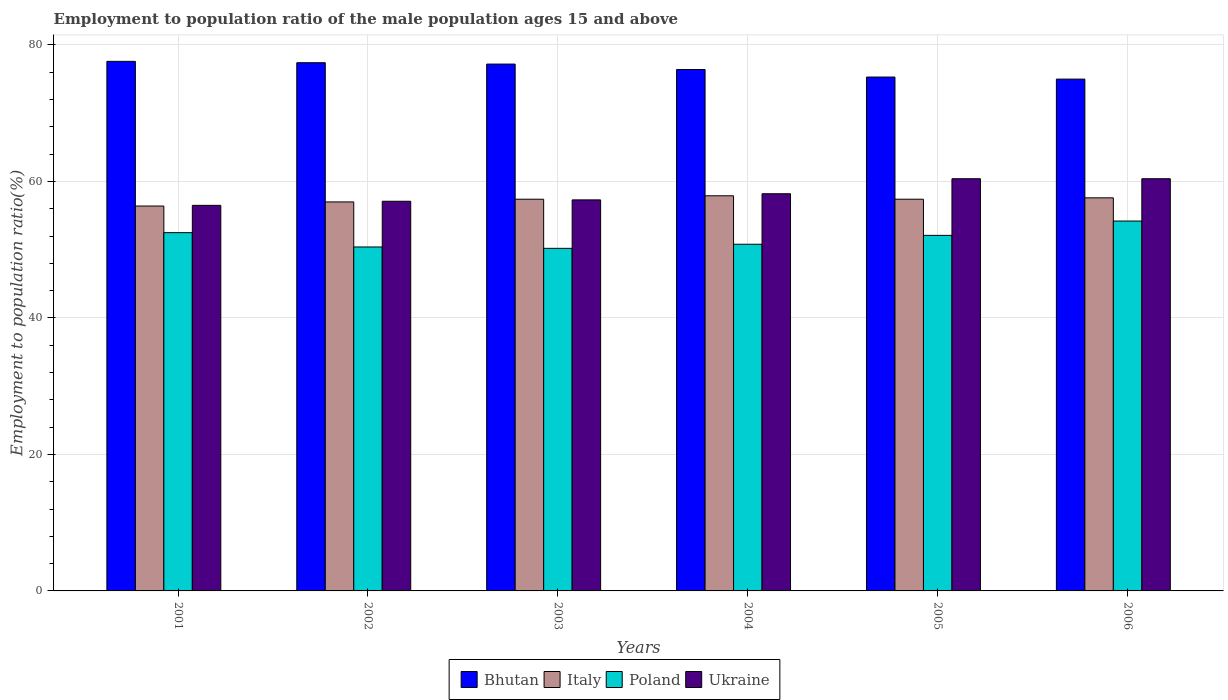How many different coloured bars are there?
Your response must be concise. 4. Are the number of bars per tick equal to the number of legend labels?
Your response must be concise. Yes. Are the number of bars on each tick of the X-axis equal?
Provide a short and direct response. Yes. How many bars are there on the 6th tick from the left?
Your response must be concise. 4. What is the label of the 4th group of bars from the left?
Offer a very short reply. 2004. In how many cases, is the number of bars for a given year not equal to the number of legend labels?
Provide a succinct answer. 0. What is the employment to population ratio in Ukraine in 2002?
Offer a very short reply. 57.1. Across all years, what is the maximum employment to population ratio in Ukraine?
Offer a very short reply. 60.4. Across all years, what is the minimum employment to population ratio in Ukraine?
Your answer should be compact. 56.5. What is the total employment to population ratio in Ukraine in the graph?
Your answer should be very brief. 349.9. What is the difference between the employment to population ratio in Italy in 2001 and that in 2003?
Make the answer very short. -1. What is the difference between the employment to population ratio in Poland in 2001 and the employment to population ratio in Bhutan in 2004?
Your response must be concise. -23.9. What is the average employment to population ratio in Ukraine per year?
Your answer should be very brief. 58.32. In the year 2004, what is the difference between the employment to population ratio in Poland and employment to population ratio in Bhutan?
Your answer should be compact. -25.6. What is the ratio of the employment to population ratio in Ukraine in 2002 to that in 2003?
Your response must be concise. 1. Is the difference between the employment to population ratio in Poland in 2003 and 2004 greater than the difference between the employment to population ratio in Bhutan in 2003 and 2004?
Provide a short and direct response. No. What is the difference between the highest and the second highest employment to population ratio in Italy?
Offer a terse response. 0.3. In how many years, is the employment to population ratio in Bhutan greater than the average employment to population ratio in Bhutan taken over all years?
Your answer should be very brief. 3. Is it the case that in every year, the sum of the employment to population ratio in Bhutan and employment to population ratio in Poland is greater than the sum of employment to population ratio in Ukraine and employment to population ratio in Italy?
Offer a terse response. No. What does the 4th bar from the left in 2005 represents?
Offer a very short reply. Ukraine. Is it the case that in every year, the sum of the employment to population ratio in Poland and employment to population ratio in Italy is greater than the employment to population ratio in Ukraine?
Offer a terse response. Yes. How many bars are there?
Ensure brevity in your answer.  24. Are all the bars in the graph horizontal?
Give a very brief answer. No. How many years are there in the graph?
Ensure brevity in your answer.  6. Does the graph contain any zero values?
Offer a terse response. No. How many legend labels are there?
Offer a terse response. 4. How are the legend labels stacked?
Your answer should be compact. Horizontal. What is the title of the graph?
Offer a very short reply. Employment to population ratio of the male population ages 15 and above. Does "Venezuela" appear as one of the legend labels in the graph?
Keep it short and to the point. No. What is the label or title of the X-axis?
Offer a very short reply. Years. What is the label or title of the Y-axis?
Make the answer very short. Employment to population ratio(%). What is the Employment to population ratio(%) in Bhutan in 2001?
Your answer should be very brief. 77.6. What is the Employment to population ratio(%) in Italy in 2001?
Offer a very short reply. 56.4. What is the Employment to population ratio(%) of Poland in 2001?
Provide a short and direct response. 52.5. What is the Employment to population ratio(%) in Ukraine in 2001?
Your response must be concise. 56.5. What is the Employment to population ratio(%) of Bhutan in 2002?
Give a very brief answer. 77.4. What is the Employment to population ratio(%) in Italy in 2002?
Your answer should be compact. 57. What is the Employment to population ratio(%) in Poland in 2002?
Your response must be concise. 50.4. What is the Employment to population ratio(%) in Ukraine in 2002?
Your answer should be compact. 57.1. What is the Employment to population ratio(%) in Bhutan in 2003?
Offer a terse response. 77.2. What is the Employment to population ratio(%) of Italy in 2003?
Ensure brevity in your answer.  57.4. What is the Employment to population ratio(%) in Poland in 2003?
Offer a terse response. 50.2. What is the Employment to population ratio(%) of Ukraine in 2003?
Make the answer very short. 57.3. What is the Employment to population ratio(%) in Bhutan in 2004?
Your response must be concise. 76.4. What is the Employment to population ratio(%) in Italy in 2004?
Offer a very short reply. 57.9. What is the Employment to population ratio(%) of Poland in 2004?
Your response must be concise. 50.8. What is the Employment to population ratio(%) in Ukraine in 2004?
Offer a terse response. 58.2. What is the Employment to population ratio(%) of Bhutan in 2005?
Ensure brevity in your answer.  75.3. What is the Employment to population ratio(%) of Italy in 2005?
Your answer should be compact. 57.4. What is the Employment to population ratio(%) of Poland in 2005?
Offer a terse response. 52.1. What is the Employment to population ratio(%) of Ukraine in 2005?
Your answer should be very brief. 60.4. What is the Employment to population ratio(%) of Bhutan in 2006?
Provide a succinct answer. 75. What is the Employment to population ratio(%) in Italy in 2006?
Your response must be concise. 57.6. What is the Employment to population ratio(%) in Poland in 2006?
Give a very brief answer. 54.2. What is the Employment to population ratio(%) in Ukraine in 2006?
Offer a very short reply. 60.4. Across all years, what is the maximum Employment to population ratio(%) of Bhutan?
Your answer should be very brief. 77.6. Across all years, what is the maximum Employment to population ratio(%) of Italy?
Offer a terse response. 57.9. Across all years, what is the maximum Employment to population ratio(%) in Poland?
Offer a terse response. 54.2. Across all years, what is the maximum Employment to population ratio(%) in Ukraine?
Offer a very short reply. 60.4. Across all years, what is the minimum Employment to population ratio(%) in Bhutan?
Offer a very short reply. 75. Across all years, what is the minimum Employment to population ratio(%) in Italy?
Keep it short and to the point. 56.4. Across all years, what is the minimum Employment to population ratio(%) of Poland?
Offer a very short reply. 50.2. Across all years, what is the minimum Employment to population ratio(%) in Ukraine?
Give a very brief answer. 56.5. What is the total Employment to population ratio(%) of Bhutan in the graph?
Provide a succinct answer. 458.9. What is the total Employment to population ratio(%) of Italy in the graph?
Provide a succinct answer. 343.7. What is the total Employment to population ratio(%) in Poland in the graph?
Provide a succinct answer. 310.2. What is the total Employment to population ratio(%) of Ukraine in the graph?
Offer a very short reply. 349.9. What is the difference between the Employment to population ratio(%) of Bhutan in 2001 and that in 2002?
Keep it short and to the point. 0.2. What is the difference between the Employment to population ratio(%) of Italy in 2001 and that in 2003?
Provide a succinct answer. -1. What is the difference between the Employment to population ratio(%) in Ukraine in 2001 and that in 2003?
Make the answer very short. -0.8. What is the difference between the Employment to population ratio(%) of Italy in 2001 and that in 2004?
Make the answer very short. -1.5. What is the difference between the Employment to population ratio(%) in Poland in 2001 and that in 2004?
Your answer should be compact. 1.7. What is the difference between the Employment to population ratio(%) in Ukraine in 2001 and that in 2004?
Ensure brevity in your answer.  -1.7. What is the difference between the Employment to population ratio(%) in Italy in 2001 and that in 2005?
Offer a terse response. -1. What is the difference between the Employment to population ratio(%) in Poland in 2001 and that in 2005?
Your answer should be compact. 0.4. What is the difference between the Employment to population ratio(%) of Bhutan in 2001 and that in 2006?
Make the answer very short. 2.6. What is the difference between the Employment to population ratio(%) in Ukraine in 2001 and that in 2006?
Give a very brief answer. -3.9. What is the difference between the Employment to population ratio(%) of Poland in 2002 and that in 2003?
Your answer should be very brief. 0.2. What is the difference between the Employment to population ratio(%) of Bhutan in 2002 and that in 2004?
Provide a succinct answer. 1. What is the difference between the Employment to population ratio(%) in Ukraine in 2002 and that in 2004?
Make the answer very short. -1.1. What is the difference between the Employment to population ratio(%) in Ukraine in 2002 and that in 2005?
Give a very brief answer. -3.3. What is the difference between the Employment to population ratio(%) of Bhutan in 2003 and that in 2004?
Your answer should be very brief. 0.8. What is the difference between the Employment to population ratio(%) in Ukraine in 2003 and that in 2004?
Offer a very short reply. -0.9. What is the difference between the Employment to population ratio(%) of Italy in 2003 and that in 2005?
Provide a succinct answer. 0. What is the difference between the Employment to population ratio(%) of Poland in 2003 and that in 2005?
Provide a short and direct response. -1.9. What is the difference between the Employment to population ratio(%) of Bhutan in 2003 and that in 2006?
Your answer should be compact. 2.2. What is the difference between the Employment to population ratio(%) of Poland in 2003 and that in 2006?
Provide a succinct answer. -4. What is the difference between the Employment to population ratio(%) of Italy in 2004 and that in 2005?
Offer a very short reply. 0.5. What is the difference between the Employment to population ratio(%) in Poland in 2004 and that in 2005?
Make the answer very short. -1.3. What is the difference between the Employment to population ratio(%) of Ukraine in 2004 and that in 2005?
Provide a short and direct response. -2.2. What is the difference between the Employment to population ratio(%) in Italy in 2004 and that in 2006?
Offer a terse response. 0.3. What is the difference between the Employment to population ratio(%) in Poland in 2004 and that in 2006?
Provide a succinct answer. -3.4. What is the difference between the Employment to population ratio(%) in Ukraine in 2004 and that in 2006?
Give a very brief answer. -2.2. What is the difference between the Employment to population ratio(%) in Bhutan in 2005 and that in 2006?
Provide a succinct answer. 0.3. What is the difference between the Employment to population ratio(%) of Italy in 2005 and that in 2006?
Provide a succinct answer. -0.2. What is the difference between the Employment to population ratio(%) in Poland in 2005 and that in 2006?
Offer a terse response. -2.1. What is the difference between the Employment to population ratio(%) of Ukraine in 2005 and that in 2006?
Offer a terse response. 0. What is the difference between the Employment to population ratio(%) of Bhutan in 2001 and the Employment to population ratio(%) of Italy in 2002?
Make the answer very short. 20.6. What is the difference between the Employment to population ratio(%) of Bhutan in 2001 and the Employment to population ratio(%) of Poland in 2002?
Provide a succinct answer. 27.2. What is the difference between the Employment to population ratio(%) in Bhutan in 2001 and the Employment to population ratio(%) in Ukraine in 2002?
Your response must be concise. 20.5. What is the difference between the Employment to population ratio(%) of Italy in 2001 and the Employment to population ratio(%) of Poland in 2002?
Your response must be concise. 6. What is the difference between the Employment to population ratio(%) of Italy in 2001 and the Employment to population ratio(%) of Ukraine in 2002?
Provide a succinct answer. -0.7. What is the difference between the Employment to population ratio(%) of Bhutan in 2001 and the Employment to population ratio(%) of Italy in 2003?
Ensure brevity in your answer.  20.2. What is the difference between the Employment to population ratio(%) of Bhutan in 2001 and the Employment to population ratio(%) of Poland in 2003?
Offer a terse response. 27.4. What is the difference between the Employment to population ratio(%) in Bhutan in 2001 and the Employment to population ratio(%) in Ukraine in 2003?
Make the answer very short. 20.3. What is the difference between the Employment to population ratio(%) in Italy in 2001 and the Employment to population ratio(%) in Poland in 2003?
Offer a very short reply. 6.2. What is the difference between the Employment to population ratio(%) in Italy in 2001 and the Employment to population ratio(%) in Ukraine in 2003?
Provide a short and direct response. -0.9. What is the difference between the Employment to population ratio(%) in Bhutan in 2001 and the Employment to population ratio(%) in Poland in 2004?
Offer a terse response. 26.8. What is the difference between the Employment to population ratio(%) of Bhutan in 2001 and the Employment to population ratio(%) of Ukraine in 2004?
Provide a short and direct response. 19.4. What is the difference between the Employment to population ratio(%) in Italy in 2001 and the Employment to population ratio(%) in Ukraine in 2004?
Your response must be concise. -1.8. What is the difference between the Employment to population ratio(%) of Bhutan in 2001 and the Employment to population ratio(%) of Italy in 2005?
Provide a succinct answer. 20.2. What is the difference between the Employment to population ratio(%) of Bhutan in 2001 and the Employment to population ratio(%) of Ukraine in 2005?
Your response must be concise. 17.2. What is the difference between the Employment to population ratio(%) of Italy in 2001 and the Employment to population ratio(%) of Poland in 2005?
Keep it short and to the point. 4.3. What is the difference between the Employment to population ratio(%) in Bhutan in 2001 and the Employment to population ratio(%) in Italy in 2006?
Make the answer very short. 20. What is the difference between the Employment to population ratio(%) of Bhutan in 2001 and the Employment to population ratio(%) of Poland in 2006?
Give a very brief answer. 23.4. What is the difference between the Employment to population ratio(%) in Bhutan in 2001 and the Employment to population ratio(%) in Ukraine in 2006?
Offer a terse response. 17.2. What is the difference between the Employment to population ratio(%) in Poland in 2001 and the Employment to population ratio(%) in Ukraine in 2006?
Offer a terse response. -7.9. What is the difference between the Employment to population ratio(%) of Bhutan in 2002 and the Employment to population ratio(%) of Poland in 2003?
Keep it short and to the point. 27.2. What is the difference between the Employment to population ratio(%) of Bhutan in 2002 and the Employment to population ratio(%) of Ukraine in 2003?
Your answer should be very brief. 20.1. What is the difference between the Employment to population ratio(%) in Bhutan in 2002 and the Employment to population ratio(%) in Poland in 2004?
Keep it short and to the point. 26.6. What is the difference between the Employment to population ratio(%) in Bhutan in 2002 and the Employment to population ratio(%) in Poland in 2005?
Make the answer very short. 25.3. What is the difference between the Employment to population ratio(%) of Italy in 2002 and the Employment to population ratio(%) of Ukraine in 2005?
Make the answer very short. -3.4. What is the difference between the Employment to population ratio(%) in Poland in 2002 and the Employment to population ratio(%) in Ukraine in 2005?
Offer a very short reply. -10. What is the difference between the Employment to population ratio(%) of Bhutan in 2002 and the Employment to population ratio(%) of Italy in 2006?
Your response must be concise. 19.8. What is the difference between the Employment to population ratio(%) in Bhutan in 2002 and the Employment to population ratio(%) in Poland in 2006?
Give a very brief answer. 23.2. What is the difference between the Employment to population ratio(%) of Bhutan in 2002 and the Employment to population ratio(%) of Ukraine in 2006?
Your response must be concise. 17. What is the difference between the Employment to population ratio(%) in Italy in 2002 and the Employment to population ratio(%) in Ukraine in 2006?
Offer a very short reply. -3.4. What is the difference between the Employment to population ratio(%) of Poland in 2002 and the Employment to population ratio(%) of Ukraine in 2006?
Give a very brief answer. -10. What is the difference between the Employment to population ratio(%) in Bhutan in 2003 and the Employment to population ratio(%) in Italy in 2004?
Make the answer very short. 19.3. What is the difference between the Employment to population ratio(%) of Bhutan in 2003 and the Employment to population ratio(%) of Poland in 2004?
Your answer should be very brief. 26.4. What is the difference between the Employment to population ratio(%) in Bhutan in 2003 and the Employment to population ratio(%) in Ukraine in 2004?
Your answer should be very brief. 19. What is the difference between the Employment to population ratio(%) of Italy in 2003 and the Employment to population ratio(%) of Ukraine in 2004?
Provide a succinct answer. -0.8. What is the difference between the Employment to population ratio(%) in Poland in 2003 and the Employment to population ratio(%) in Ukraine in 2004?
Keep it short and to the point. -8. What is the difference between the Employment to population ratio(%) in Bhutan in 2003 and the Employment to population ratio(%) in Italy in 2005?
Offer a terse response. 19.8. What is the difference between the Employment to population ratio(%) of Bhutan in 2003 and the Employment to population ratio(%) of Poland in 2005?
Your response must be concise. 25.1. What is the difference between the Employment to population ratio(%) in Bhutan in 2003 and the Employment to population ratio(%) in Ukraine in 2005?
Make the answer very short. 16.8. What is the difference between the Employment to population ratio(%) of Italy in 2003 and the Employment to population ratio(%) of Ukraine in 2005?
Ensure brevity in your answer.  -3. What is the difference between the Employment to population ratio(%) of Bhutan in 2003 and the Employment to population ratio(%) of Italy in 2006?
Your answer should be compact. 19.6. What is the difference between the Employment to population ratio(%) of Bhutan in 2003 and the Employment to population ratio(%) of Poland in 2006?
Give a very brief answer. 23. What is the difference between the Employment to population ratio(%) of Bhutan in 2003 and the Employment to population ratio(%) of Ukraine in 2006?
Offer a very short reply. 16.8. What is the difference between the Employment to population ratio(%) in Italy in 2003 and the Employment to population ratio(%) in Poland in 2006?
Your answer should be compact. 3.2. What is the difference between the Employment to population ratio(%) of Bhutan in 2004 and the Employment to population ratio(%) of Italy in 2005?
Your response must be concise. 19. What is the difference between the Employment to population ratio(%) in Bhutan in 2004 and the Employment to population ratio(%) in Poland in 2005?
Your answer should be very brief. 24.3. What is the difference between the Employment to population ratio(%) in Bhutan in 2004 and the Employment to population ratio(%) in Ukraine in 2005?
Provide a short and direct response. 16. What is the difference between the Employment to population ratio(%) of Italy in 2004 and the Employment to population ratio(%) of Poland in 2005?
Ensure brevity in your answer.  5.8. What is the difference between the Employment to population ratio(%) in Italy in 2004 and the Employment to population ratio(%) in Ukraine in 2005?
Provide a succinct answer. -2.5. What is the difference between the Employment to population ratio(%) in Poland in 2004 and the Employment to population ratio(%) in Ukraine in 2005?
Make the answer very short. -9.6. What is the difference between the Employment to population ratio(%) of Bhutan in 2004 and the Employment to population ratio(%) of Italy in 2006?
Make the answer very short. 18.8. What is the difference between the Employment to population ratio(%) in Italy in 2004 and the Employment to population ratio(%) in Ukraine in 2006?
Offer a terse response. -2.5. What is the difference between the Employment to population ratio(%) in Poland in 2004 and the Employment to population ratio(%) in Ukraine in 2006?
Make the answer very short. -9.6. What is the difference between the Employment to population ratio(%) in Bhutan in 2005 and the Employment to population ratio(%) in Italy in 2006?
Offer a very short reply. 17.7. What is the difference between the Employment to population ratio(%) in Bhutan in 2005 and the Employment to population ratio(%) in Poland in 2006?
Give a very brief answer. 21.1. What is the difference between the Employment to population ratio(%) of Bhutan in 2005 and the Employment to population ratio(%) of Ukraine in 2006?
Ensure brevity in your answer.  14.9. What is the difference between the Employment to population ratio(%) of Italy in 2005 and the Employment to population ratio(%) of Poland in 2006?
Provide a succinct answer. 3.2. What is the average Employment to population ratio(%) in Bhutan per year?
Provide a short and direct response. 76.48. What is the average Employment to population ratio(%) of Italy per year?
Offer a terse response. 57.28. What is the average Employment to population ratio(%) of Poland per year?
Give a very brief answer. 51.7. What is the average Employment to population ratio(%) in Ukraine per year?
Keep it short and to the point. 58.32. In the year 2001, what is the difference between the Employment to population ratio(%) in Bhutan and Employment to population ratio(%) in Italy?
Ensure brevity in your answer.  21.2. In the year 2001, what is the difference between the Employment to population ratio(%) of Bhutan and Employment to population ratio(%) of Poland?
Provide a short and direct response. 25.1. In the year 2001, what is the difference between the Employment to population ratio(%) in Bhutan and Employment to population ratio(%) in Ukraine?
Your response must be concise. 21.1. In the year 2001, what is the difference between the Employment to population ratio(%) in Italy and Employment to population ratio(%) in Poland?
Provide a succinct answer. 3.9. In the year 2001, what is the difference between the Employment to population ratio(%) of Italy and Employment to population ratio(%) of Ukraine?
Your response must be concise. -0.1. In the year 2001, what is the difference between the Employment to population ratio(%) in Poland and Employment to population ratio(%) in Ukraine?
Keep it short and to the point. -4. In the year 2002, what is the difference between the Employment to population ratio(%) in Bhutan and Employment to population ratio(%) in Italy?
Ensure brevity in your answer.  20.4. In the year 2002, what is the difference between the Employment to population ratio(%) of Bhutan and Employment to population ratio(%) of Ukraine?
Ensure brevity in your answer.  20.3. In the year 2002, what is the difference between the Employment to population ratio(%) of Italy and Employment to population ratio(%) of Poland?
Ensure brevity in your answer.  6.6. In the year 2002, what is the difference between the Employment to population ratio(%) in Poland and Employment to population ratio(%) in Ukraine?
Provide a short and direct response. -6.7. In the year 2003, what is the difference between the Employment to population ratio(%) of Bhutan and Employment to population ratio(%) of Italy?
Your response must be concise. 19.8. In the year 2003, what is the difference between the Employment to population ratio(%) in Bhutan and Employment to population ratio(%) in Poland?
Offer a terse response. 27. In the year 2004, what is the difference between the Employment to population ratio(%) in Bhutan and Employment to population ratio(%) in Italy?
Keep it short and to the point. 18.5. In the year 2004, what is the difference between the Employment to population ratio(%) of Bhutan and Employment to population ratio(%) of Poland?
Make the answer very short. 25.6. In the year 2004, what is the difference between the Employment to population ratio(%) of Bhutan and Employment to population ratio(%) of Ukraine?
Give a very brief answer. 18.2. In the year 2004, what is the difference between the Employment to population ratio(%) in Italy and Employment to population ratio(%) in Poland?
Your answer should be very brief. 7.1. In the year 2004, what is the difference between the Employment to population ratio(%) of Italy and Employment to population ratio(%) of Ukraine?
Offer a terse response. -0.3. In the year 2005, what is the difference between the Employment to population ratio(%) of Bhutan and Employment to population ratio(%) of Poland?
Your response must be concise. 23.2. In the year 2005, what is the difference between the Employment to population ratio(%) in Bhutan and Employment to population ratio(%) in Ukraine?
Make the answer very short. 14.9. In the year 2005, what is the difference between the Employment to population ratio(%) in Italy and Employment to population ratio(%) in Poland?
Your response must be concise. 5.3. In the year 2006, what is the difference between the Employment to population ratio(%) of Bhutan and Employment to population ratio(%) of Poland?
Provide a succinct answer. 20.8. In the year 2006, what is the difference between the Employment to population ratio(%) of Bhutan and Employment to population ratio(%) of Ukraine?
Offer a very short reply. 14.6. In the year 2006, what is the difference between the Employment to population ratio(%) in Italy and Employment to population ratio(%) in Poland?
Give a very brief answer. 3.4. In the year 2006, what is the difference between the Employment to population ratio(%) of Italy and Employment to population ratio(%) of Ukraine?
Your response must be concise. -2.8. What is the ratio of the Employment to population ratio(%) in Bhutan in 2001 to that in 2002?
Your response must be concise. 1. What is the ratio of the Employment to population ratio(%) of Poland in 2001 to that in 2002?
Provide a succinct answer. 1.04. What is the ratio of the Employment to population ratio(%) of Ukraine in 2001 to that in 2002?
Provide a short and direct response. 0.99. What is the ratio of the Employment to population ratio(%) of Italy in 2001 to that in 2003?
Your response must be concise. 0.98. What is the ratio of the Employment to population ratio(%) of Poland in 2001 to that in 2003?
Ensure brevity in your answer.  1.05. What is the ratio of the Employment to population ratio(%) in Ukraine in 2001 to that in 2003?
Make the answer very short. 0.99. What is the ratio of the Employment to population ratio(%) of Bhutan in 2001 to that in 2004?
Keep it short and to the point. 1.02. What is the ratio of the Employment to population ratio(%) in Italy in 2001 to that in 2004?
Your answer should be compact. 0.97. What is the ratio of the Employment to population ratio(%) of Poland in 2001 to that in 2004?
Offer a very short reply. 1.03. What is the ratio of the Employment to population ratio(%) in Ukraine in 2001 to that in 2004?
Make the answer very short. 0.97. What is the ratio of the Employment to population ratio(%) of Bhutan in 2001 to that in 2005?
Your answer should be very brief. 1.03. What is the ratio of the Employment to population ratio(%) of Italy in 2001 to that in 2005?
Keep it short and to the point. 0.98. What is the ratio of the Employment to population ratio(%) in Poland in 2001 to that in 2005?
Ensure brevity in your answer.  1.01. What is the ratio of the Employment to population ratio(%) in Ukraine in 2001 to that in 2005?
Your response must be concise. 0.94. What is the ratio of the Employment to population ratio(%) in Bhutan in 2001 to that in 2006?
Your answer should be compact. 1.03. What is the ratio of the Employment to population ratio(%) in Italy in 2001 to that in 2006?
Make the answer very short. 0.98. What is the ratio of the Employment to population ratio(%) in Poland in 2001 to that in 2006?
Make the answer very short. 0.97. What is the ratio of the Employment to population ratio(%) of Ukraine in 2001 to that in 2006?
Keep it short and to the point. 0.94. What is the ratio of the Employment to population ratio(%) in Italy in 2002 to that in 2003?
Keep it short and to the point. 0.99. What is the ratio of the Employment to population ratio(%) in Ukraine in 2002 to that in 2003?
Keep it short and to the point. 1. What is the ratio of the Employment to population ratio(%) in Bhutan in 2002 to that in 2004?
Offer a very short reply. 1.01. What is the ratio of the Employment to population ratio(%) of Italy in 2002 to that in 2004?
Ensure brevity in your answer.  0.98. What is the ratio of the Employment to population ratio(%) of Ukraine in 2002 to that in 2004?
Provide a short and direct response. 0.98. What is the ratio of the Employment to population ratio(%) of Bhutan in 2002 to that in 2005?
Offer a terse response. 1.03. What is the ratio of the Employment to population ratio(%) of Poland in 2002 to that in 2005?
Your answer should be very brief. 0.97. What is the ratio of the Employment to population ratio(%) of Ukraine in 2002 to that in 2005?
Your answer should be very brief. 0.95. What is the ratio of the Employment to population ratio(%) of Bhutan in 2002 to that in 2006?
Give a very brief answer. 1.03. What is the ratio of the Employment to population ratio(%) of Poland in 2002 to that in 2006?
Provide a short and direct response. 0.93. What is the ratio of the Employment to population ratio(%) in Ukraine in 2002 to that in 2006?
Keep it short and to the point. 0.95. What is the ratio of the Employment to population ratio(%) in Bhutan in 2003 to that in 2004?
Make the answer very short. 1.01. What is the ratio of the Employment to population ratio(%) of Italy in 2003 to that in 2004?
Keep it short and to the point. 0.99. What is the ratio of the Employment to population ratio(%) in Poland in 2003 to that in 2004?
Ensure brevity in your answer.  0.99. What is the ratio of the Employment to population ratio(%) of Ukraine in 2003 to that in 2004?
Keep it short and to the point. 0.98. What is the ratio of the Employment to population ratio(%) of Bhutan in 2003 to that in 2005?
Offer a very short reply. 1.03. What is the ratio of the Employment to population ratio(%) in Italy in 2003 to that in 2005?
Ensure brevity in your answer.  1. What is the ratio of the Employment to population ratio(%) in Poland in 2003 to that in 2005?
Offer a terse response. 0.96. What is the ratio of the Employment to population ratio(%) in Ukraine in 2003 to that in 2005?
Make the answer very short. 0.95. What is the ratio of the Employment to population ratio(%) of Bhutan in 2003 to that in 2006?
Your answer should be very brief. 1.03. What is the ratio of the Employment to population ratio(%) in Poland in 2003 to that in 2006?
Ensure brevity in your answer.  0.93. What is the ratio of the Employment to population ratio(%) in Ukraine in 2003 to that in 2006?
Your answer should be compact. 0.95. What is the ratio of the Employment to population ratio(%) in Bhutan in 2004 to that in 2005?
Keep it short and to the point. 1.01. What is the ratio of the Employment to population ratio(%) of Italy in 2004 to that in 2005?
Ensure brevity in your answer.  1.01. What is the ratio of the Employment to population ratio(%) in Ukraine in 2004 to that in 2005?
Give a very brief answer. 0.96. What is the ratio of the Employment to population ratio(%) of Bhutan in 2004 to that in 2006?
Offer a terse response. 1.02. What is the ratio of the Employment to population ratio(%) in Italy in 2004 to that in 2006?
Your answer should be compact. 1.01. What is the ratio of the Employment to population ratio(%) in Poland in 2004 to that in 2006?
Give a very brief answer. 0.94. What is the ratio of the Employment to population ratio(%) of Ukraine in 2004 to that in 2006?
Give a very brief answer. 0.96. What is the ratio of the Employment to population ratio(%) in Italy in 2005 to that in 2006?
Your answer should be very brief. 1. What is the ratio of the Employment to population ratio(%) in Poland in 2005 to that in 2006?
Keep it short and to the point. 0.96. What is the difference between the highest and the second highest Employment to population ratio(%) in Poland?
Provide a short and direct response. 1.7. What is the difference between the highest and the lowest Employment to population ratio(%) in Ukraine?
Provide a short and direct response. 3.9. 